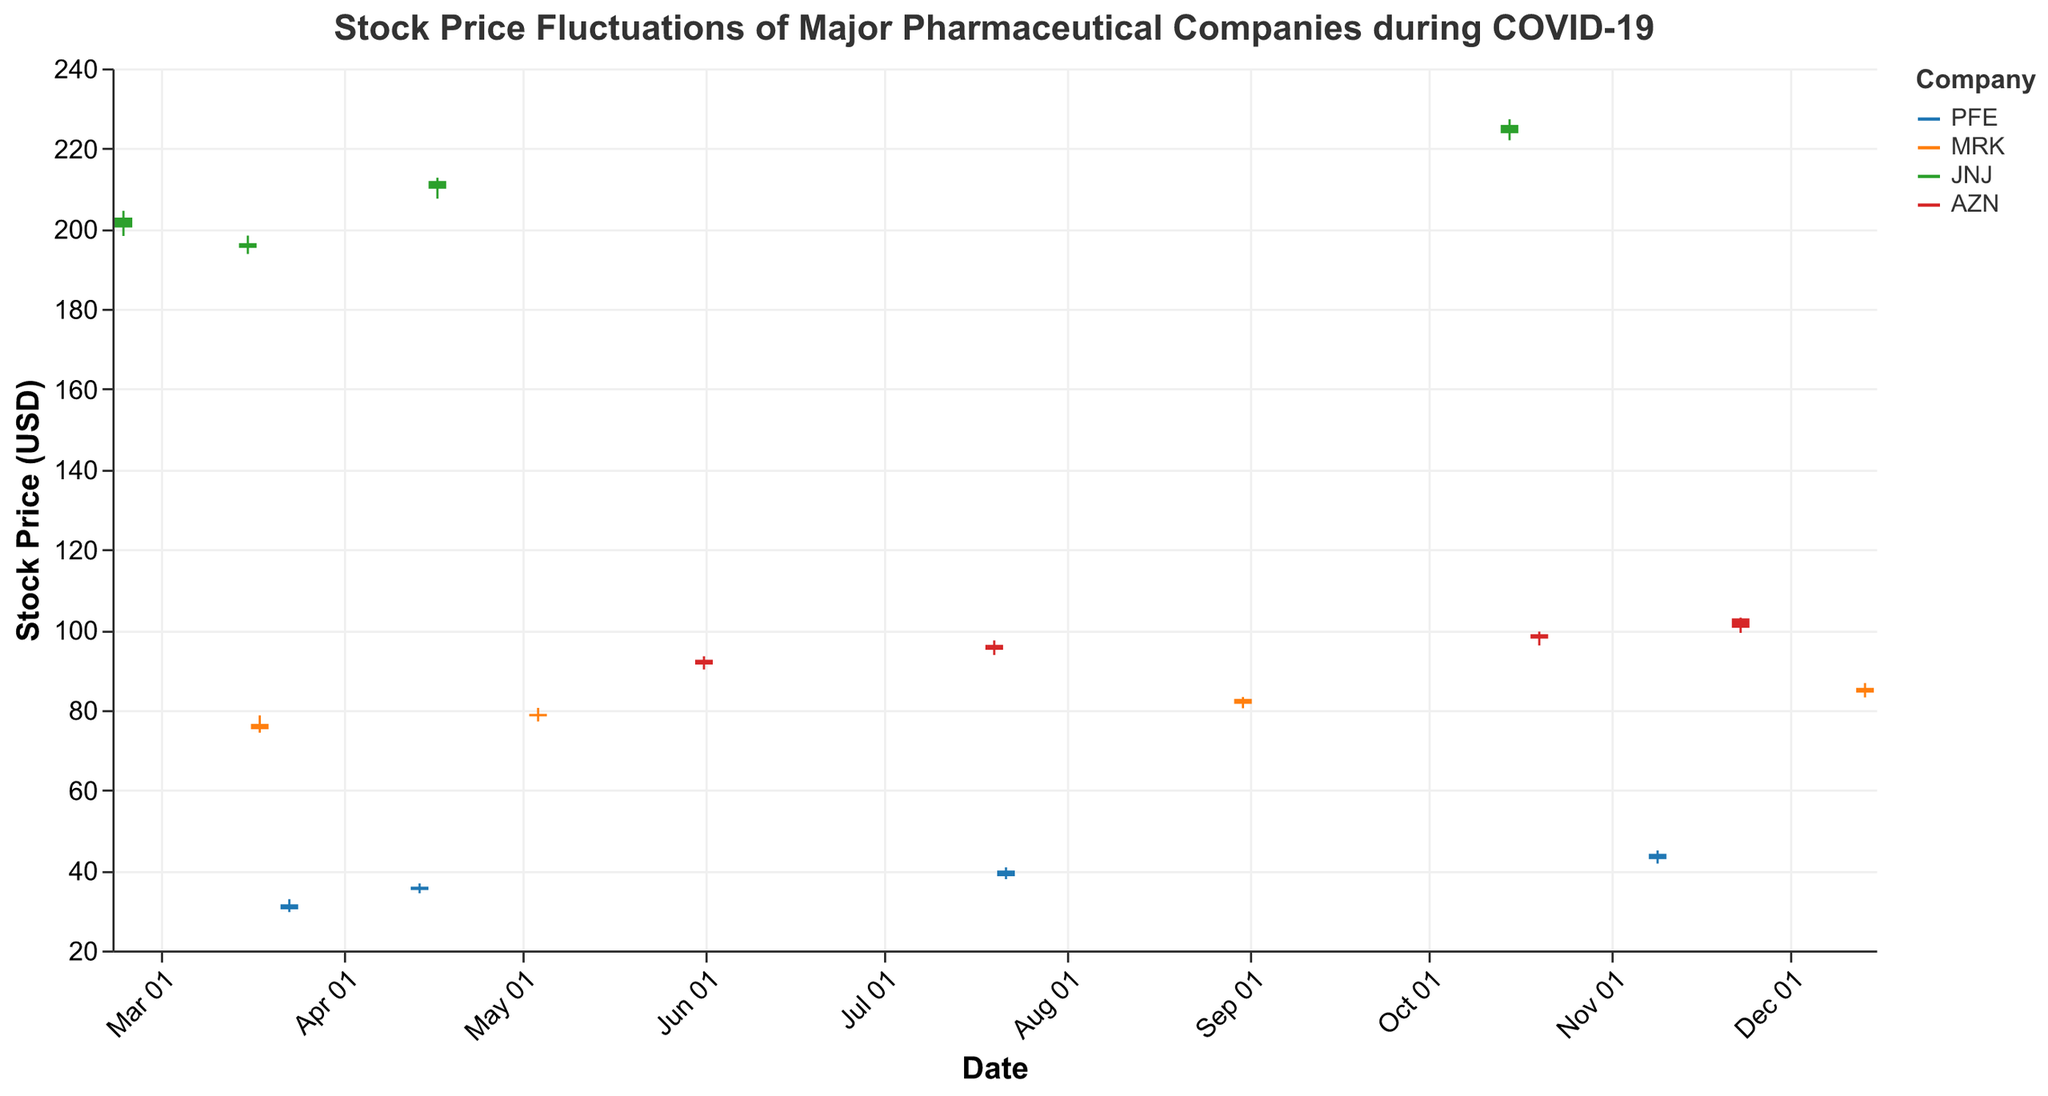When did Pfizer's stock experience a significant rise due to a positive event? Referring to the figure, look for a substantial increase in Pfizer's stock prices along with a notable event. The date is July 22, when the company posted positive Phase III trial results.
Answer: July 22, 2020 What was the impact on JNJ's stock when a clinical trial was paused? By observing the plot on the date of October 15, you can notice that Johnson & Johnson's stock fell slightly on the date of the clinical trial pause announcement.
Answer: It fell slightly Compare the stock price high points for Merck on March 18 and December 14? Examine the highest prices reached by Merck's stock on these two dates in the figure. The high on March 18 was 78.60, while on December 14, it was 86.70. Comparing these, December 14's high is greater.
Answer: December 14's high was greater Which company had the highest stock price on November 9? Look at the stock prices for all companies on November 9. Pfizer's stock price was the highest on that date.
Answer: Pfizer On which date did AstraZeneca's stock price hit its highest point during the given period? Identify the highest value of AstraZeneca's stock by locating the peak in the figure and noting the corresponding date. The highest price occurred on November 23.
Answer: November 23, 2020 How did Merck's stock close for the first event? Refer to the closing price for Merck's first listed event, which is the 'increased demand for antiviral treatments'. The closing price on March 18 was 76.50.
Answer: 76.50 What were the opening and closing prices for Johnson & Johnson's stock on April 17? Locate the specific date in the plot and identify the opening and closing bars for Johnson & Johnson. The opening price was 210.00 and the closing price was 211.90.
Answer: Opening: 210.00, Closing: 211.90 Calculate the price difference for AstraZeneca between its lowest and highest point on July 20. Find AstraZeneca's lowest and highest prices on that date. The lowest was 93.70, and the highest was 97.30. The price difference is 97.30 - 93.70.
Answer: 3.60 Which event coincided with the highest trading volume for Pfizer? Identify the day with the highest volume for Pfizer and see what event occurred. The highest volume is on November 9, when the first emergency use authorization for the vaccine was announced.
Answer: First emergency use authorization for vaccine 